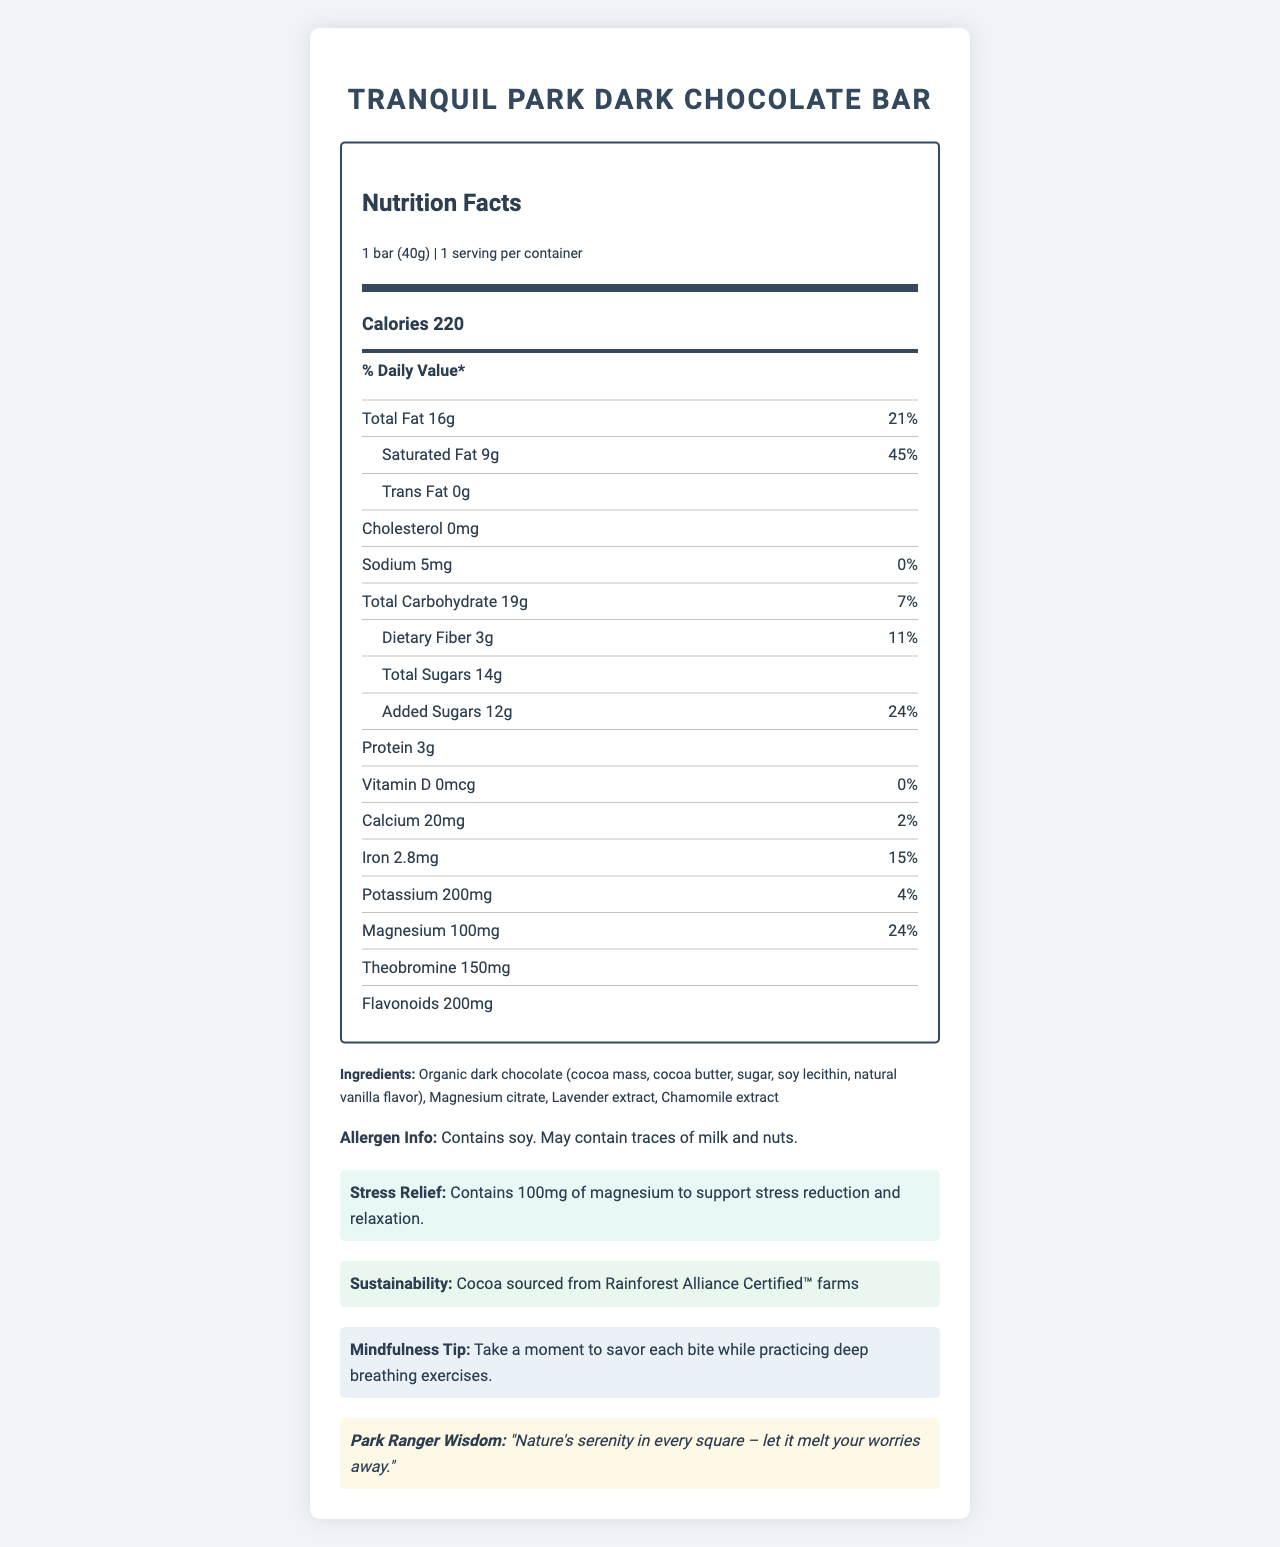what is the serving size of the Tranquil Park Dark Chocolate Bar? The serving size is specified as "1 bar (40g)" near the top of the nutrition label.
Answer: 1 bar (40g) how many calories are in one serving of the Tranquil Park Dark Chocolate Bar? The calorie content for one serving is listed as 220 calories.
Answer: 220 what percentage of the daily value of saturated fat does one serving provide? The nutrition label states that the saturated fat content provides "45% of the daily value."
Answer: 45% how much magnesium is in one serving of the Tranquil Park Dark Chocolate Bar? The magnesium content per serving is listed as "100mg."
Answer: 100mg what is the total sugar content of one serving? The total sugar content is specified as "14g" on the nutrition label.
Answer: 14g which of the following nutrients is NOT present in the Tranquil Park Dark Chocolate Bar? A. Cholesterol B. Protein C. Potassium D. Theobromine The document states that the chocolate bar contains "0mg" of cholesterol, indicating it's not present.
Answer: A. Cholesterol what is the daily value percentage of added sugars in one serving? A. 12% B. 24% C. 20% The nutrition label specifies that the added sugars provide "24% of the daily value."
Answer: B. 24% how much dietary fiber does one serving of the Tranquil Park Dark Chocolate Bar contain and what percentage of the daily value is it? The dietary fiber content is listed as "3g" which is "11% of the daily value."
Answer: 3g, 11% is this chocolate bar suitable for someone with a soy allergy? The allergen information states that the product "Contains soy."
Answer: No summarize the nutritional benefits and key features of the Tranquil Park Dark Chocolate Bar. The summary captures the key nutritional elements and stress-relief properties of the chocolate, alongside its mindfulness and sustainability angles.
Answer: The Tranquil Park Dark Chocolate Bar is a 40g serving providing 220 calories, with notable amounts of magnesium (100mg) and added sugars (12g, 24% DV). It contains 45% DV of saturated fat but no trans fat or cholesterol. This chocolate bar also includes ingredients aimed at stress relief such as magnesium citrate, and is made from cocoa sourced from Rainforest Alliance Certified™ farms. It is suitable for those seeking a mindfulness experience with added stress-relief benefits. what is the main purpose of consuming the Tranquil Park Dark Chocolate Bar according to the document? The document highlights the presence of magnesium and its claim to "support stress reduction and relaxation."
Answer: To reduce stress and promote relaxation identify two extracts included in the ingredients for additional benefits. The ingredients list includes "Lavender extract" and "Chamomile extract."
Answer: Lavender extract, Chamomile extract what is the sustainability note mentioned in the document? The sustainability note explicitly states that the cocoa is sourced from such certified farms.
Answer: Cocoa sourced from Rainforest Alliance Certified™ farms does the chocolate bar contain vitamin D? The nutrition label states that the vitamin D content is "0mcg," meaning none is present.
Answer: No what is the combined amount of carbohydrates and sugars in one serving? The total carbohydrate content is 19g, and the total sugars are 14g.
Answer: 19g (carbohydrates) + 14g (total sugars) is the amount of protein present in this bar suitable for someone looking to increase their daily protein intake significantly? The product contains only 3g of protein, which is relatively low for significantly boosting daily protein intake.
Answer: No which ingredient in the Tranquil Park Dark Chocolate Bar helps in stress reduction? The document claims that the 100mg of magnesium, which is provided by magnesium citrate, supports stress reduction.
Answer: Magnesium citrate how much iron is in one serving, and what percentage of the daily value does it represent? The iron content is listed as 2.8mg, which is 15% of the daily value.
Answer: 2.8mg, 15% what is the "Park Ranger Wisdom" mentioned in the document? The Park Ranger Wisdom at the bottom of the document advises enjoying each piece of chocolate as a serene and worry-melting experience.
Answer: "Nature's serenity in every square – let it melt your worries away." what time of day is best to consume the Tranquil Park Dark Chocolate Bar for optimal stress relief? The document does not provide information on the optimal time to consume the chocolate bar for stress relief.
Answer: Not enough information 